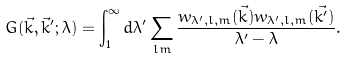<formula> <loc_0><loc_0><loc_500><loc_500>G ( \vec { k } , \vec { k } ^ { \prime } ; \lambda ) = \int _ { 1 } ^ { \infty } d \lambda ^ { \prime } \sum _ { l m } \frac { w _ { \lambda ^ { \prime } , l , m } ( \vec { k } ) { \bar { w } } _ { \lambda ^ { \prime } , l , m } ( \vec { k ^ { \prime } } ) } { \lambda ^ { \prime } - \lambda } .</formula> 